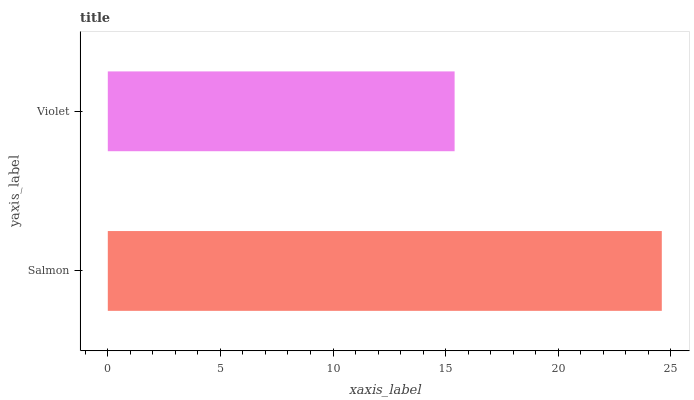Is Violet the minimum?
Answer yes or no. Yes. Is Salmon the maximum?
Answer yes or no. Yes. Is Violet the maximum?
Answer yes or no. No. Is Salmon greater than Violet?
Answer yes or no. Yes. Is Violet less than Salmon?
Answer yes or no. Yes. Is Violet greater than Salmon?
Answer yes or no. No. Is Salmon less than Violet?
Answer yes or no. No. Is Salmon the high median?
Answer yes or no. Yes. Is Violet the low median?
Answer yes or no. Yes. Is Violet the high median?
Answer yes or no. No. Is Salmon the low median?
Answer yes or no. No. 